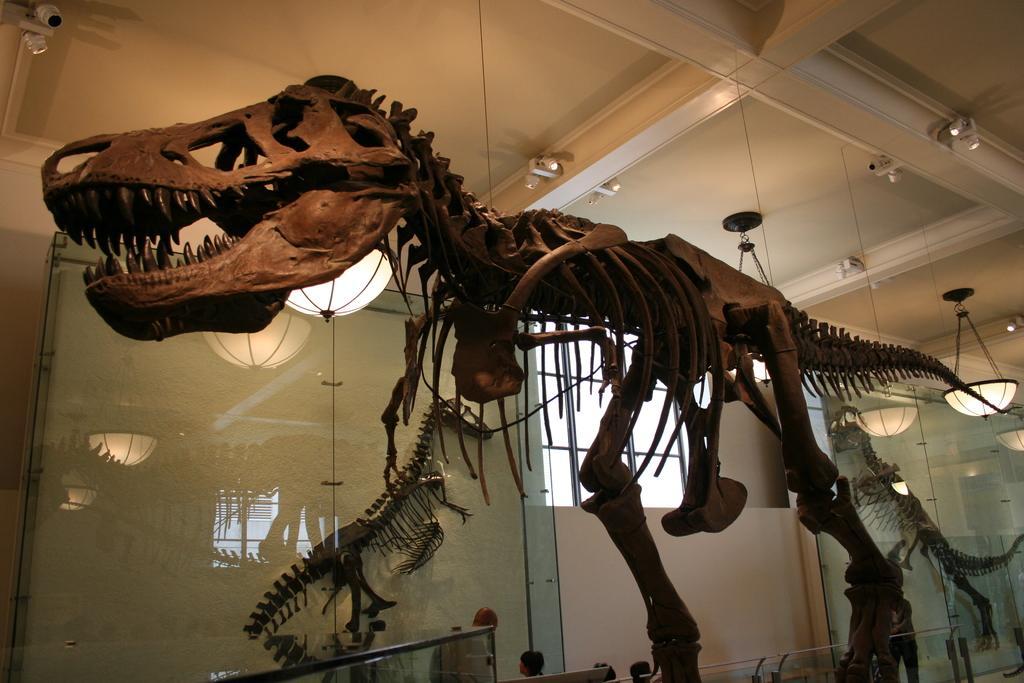Describe this image in one or two sentences. In this image we can see a dinosaur skeleton is hang from the white color roof. Behind it, we can see the white color wall, window and two more skeletons in the glass. We can see the camera in the left top of the image and lights are attached to the roof. 